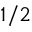Convert formula to latex. <formula><loc_0><loc_0><loc_500><loc_500>^ { 1 / 2 }</formula> 